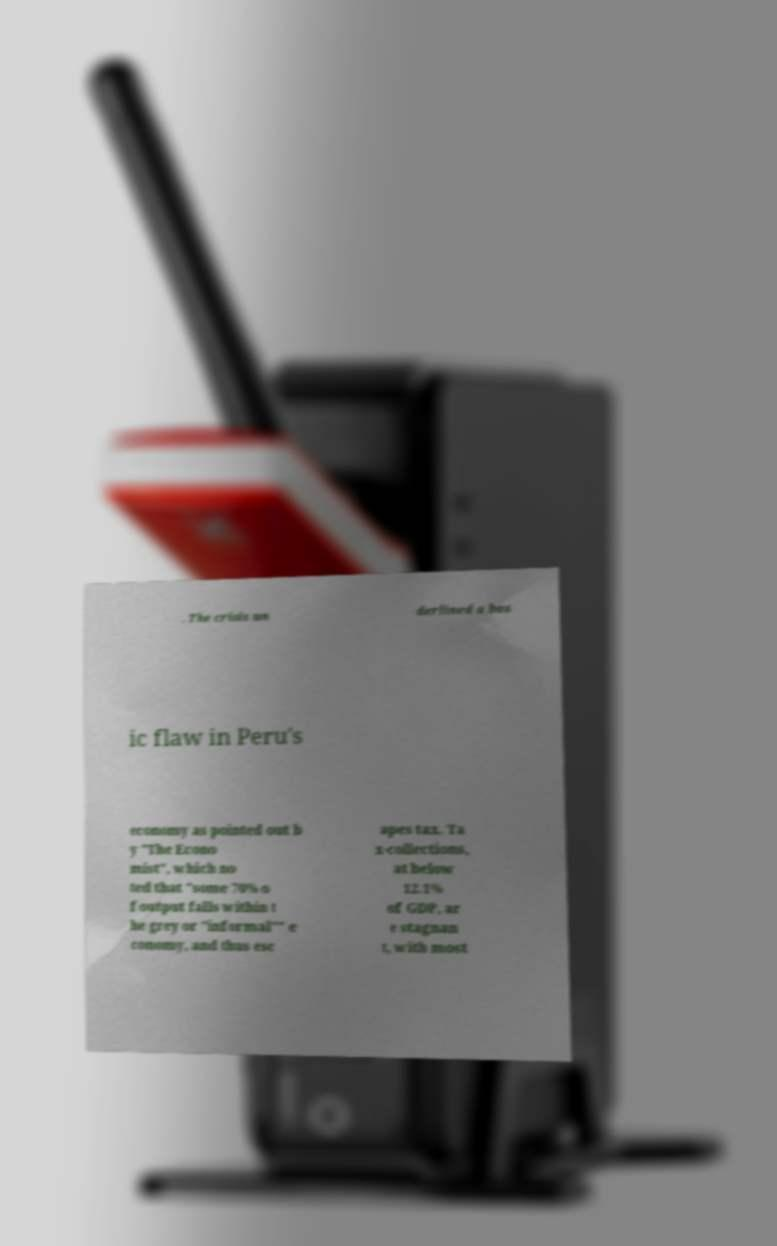What messages or text are displayed in this image? I need them in a readable, typed format. . The crisis un derlined a bas ic flaw in Peru's economy as pointed out b y "The Econo mist", which no ted that "some 70% o f output falls within t he grey or "informal"" e conomy, and thus esc apes tax. Ta x-collections, at below 12.1% of GDP, ar e stagnan t, with most 